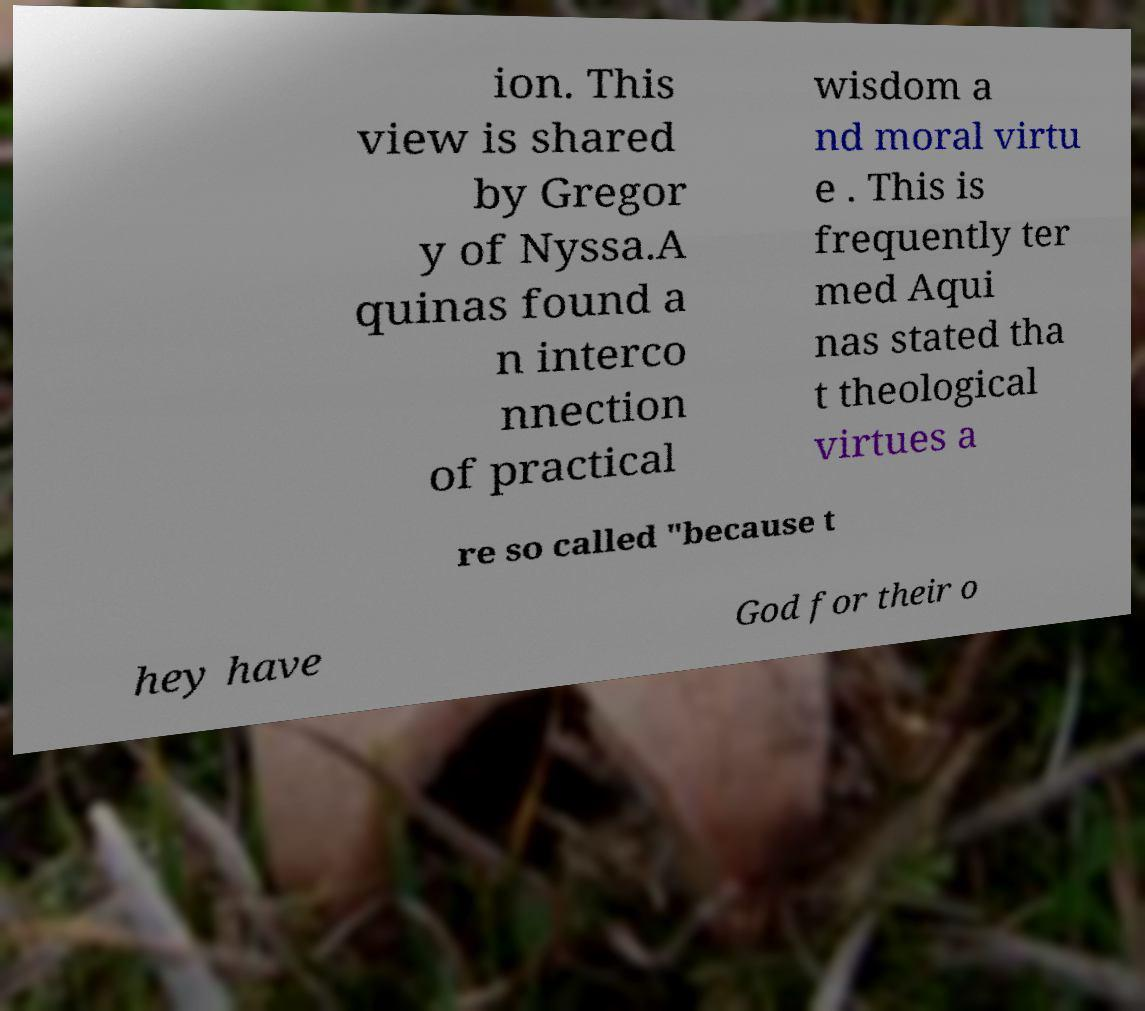For documentation purposes, I need the text within this image transcribed. Could you provide that? ion. This view is shared by Gregor y of Nyssa.A quinas found a n interco nnection of practical wisdom a nd moral virtu e . This is frequently ter med Aqui nas stated tha t theological virtues a re so called "because t hey have God for their o 